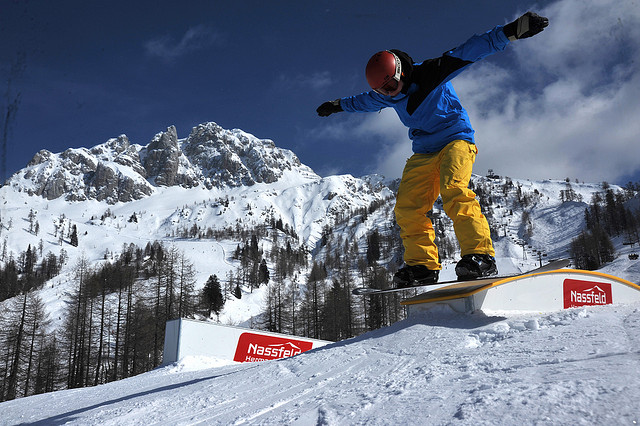Are there any animals visible in the image? No, there are no animals visible in the image. The scene is primarily focused on the snowboarder and the stunning mountainous background, which features snow-covered peaks and trees. 